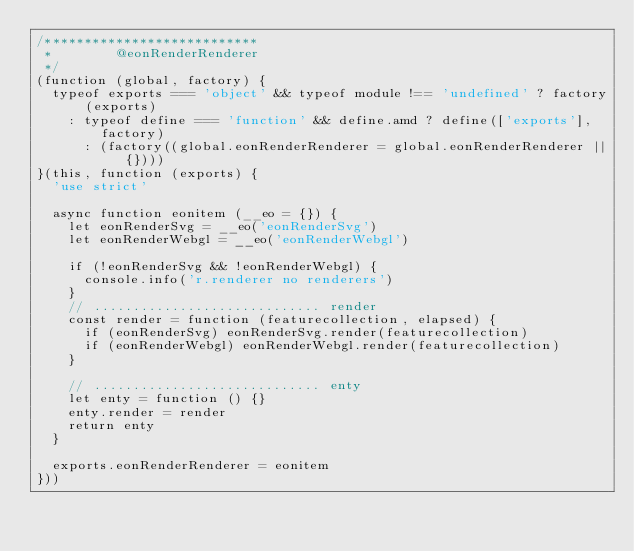<code> <loc_0><loc_0><loc_500><loc_500><_JavaScript_>/***************************
 *        @eonRenderRenderer
 */
(function (global, factory) {
  typeof exports === 'object' && typeof module !== 'undefined' ? factory(exports)
    : typeof define === 'function' && define.amd ? define(['exports'], factory)
      : (factory((global.eonRenderRenderer = global.eonRenderRenderer || {})))
}(this, function (exports) {
  'use strict'

  async function eonitem (__eo = {}) {
    let eonRenderSvg = __eo('eonRenderSvg')
    let eonRenderWebgl = __eo('eonRenderWebgl')

    if (!eonRenderSvg && !eonRenderWebgl) {
      console.info('r.renderer no renderers')
    }
    // ............................. render
    const render = function (featurecollection, elapsed) {
      if (eonRenderSvg) eonRenderSvg.render(featurecollection)
      if (eonRenderWebgl) eonRenderWebgl.render(featurecollection)
    }

    // ............................. enty
    let enty = function () {}
    enty.render = render
    return enty
  }

  exports.eonRenderRenderer = eonitem
}))
</code> 